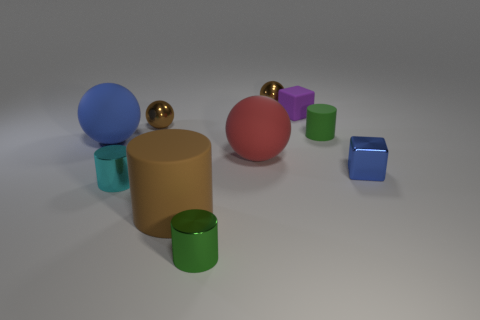Subtract all large brown cylinders. How many cylinders are left? 3 Subtract 1 spheres. How many spheres are left? 3 Subtract all green spheres. Subtract all green cylinders. How many spheres are left? 4 Subtract all cylinders. How many objects are left? 6 Subtract all small blue metallic objects. Subtract all small purple matte blocks. How many objects are left? 8 Add 1 small shiny cylinders. How many small shiny cylinders are left? 3 Add 6 brown things. How many brown things exist? 9 Subtract 0 green cubes. How many objects are left? 10 